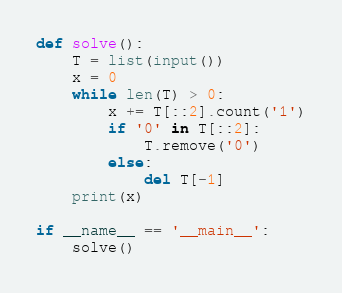<code> <loc_0><loc_0><loc_500><loc_500><_Python_>def solve():
    T = list(input())
    x = 0
    while len(T) > 0:
        x += T[::2].count('1')
        if '0' in T[::2]:
            T.remove('0')
        else:
            del T[-1]
    print(x)

if __name__ == '__main__':
    solve()
</code> 